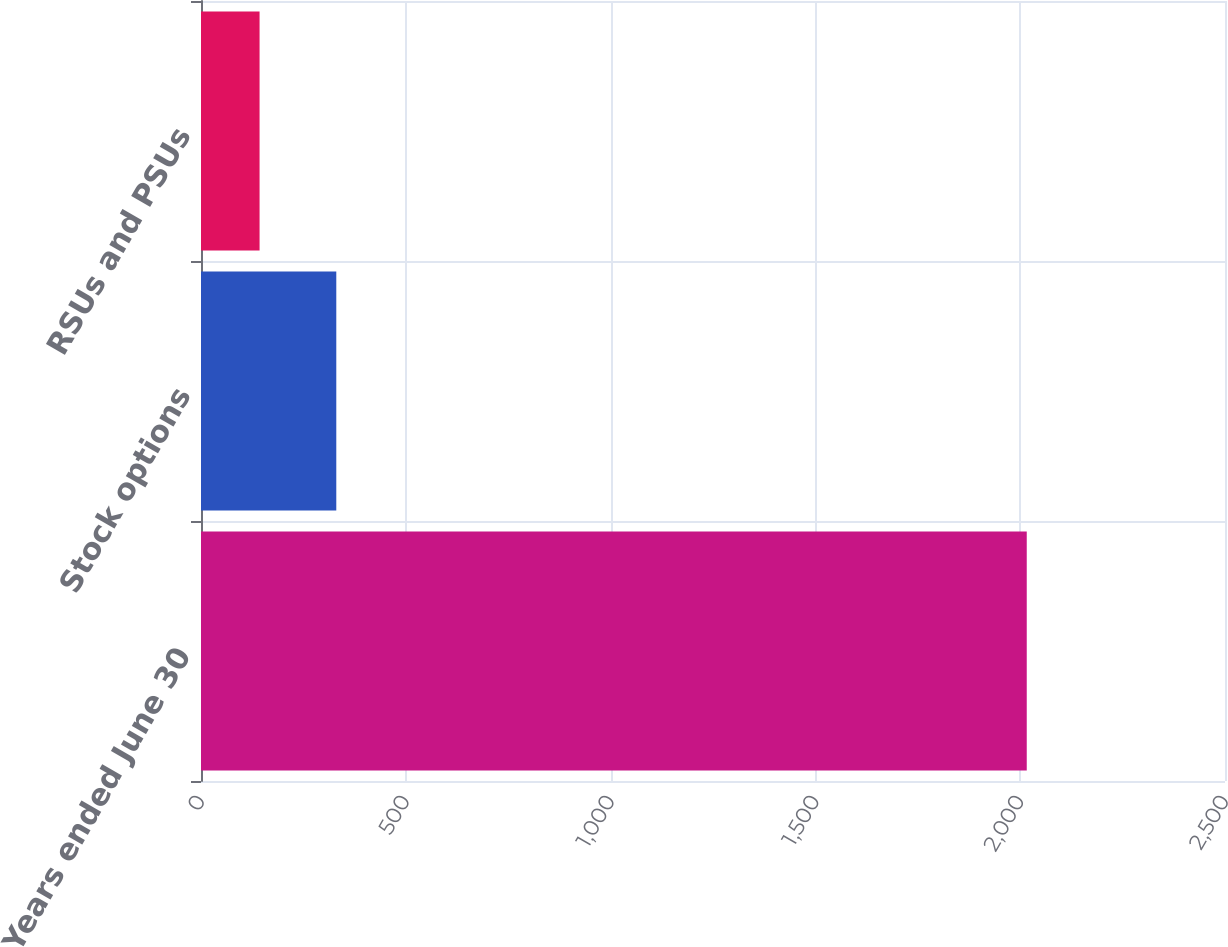<chart> <loc_0><loc_0><loc_500><loc_500><bar_chart><fcel>Years ended June 30<fcel>Stock options<fcel>RSUs and PSUs<nl><fcel>2016<fcel>330.3<fcel>143<nl></chart> 